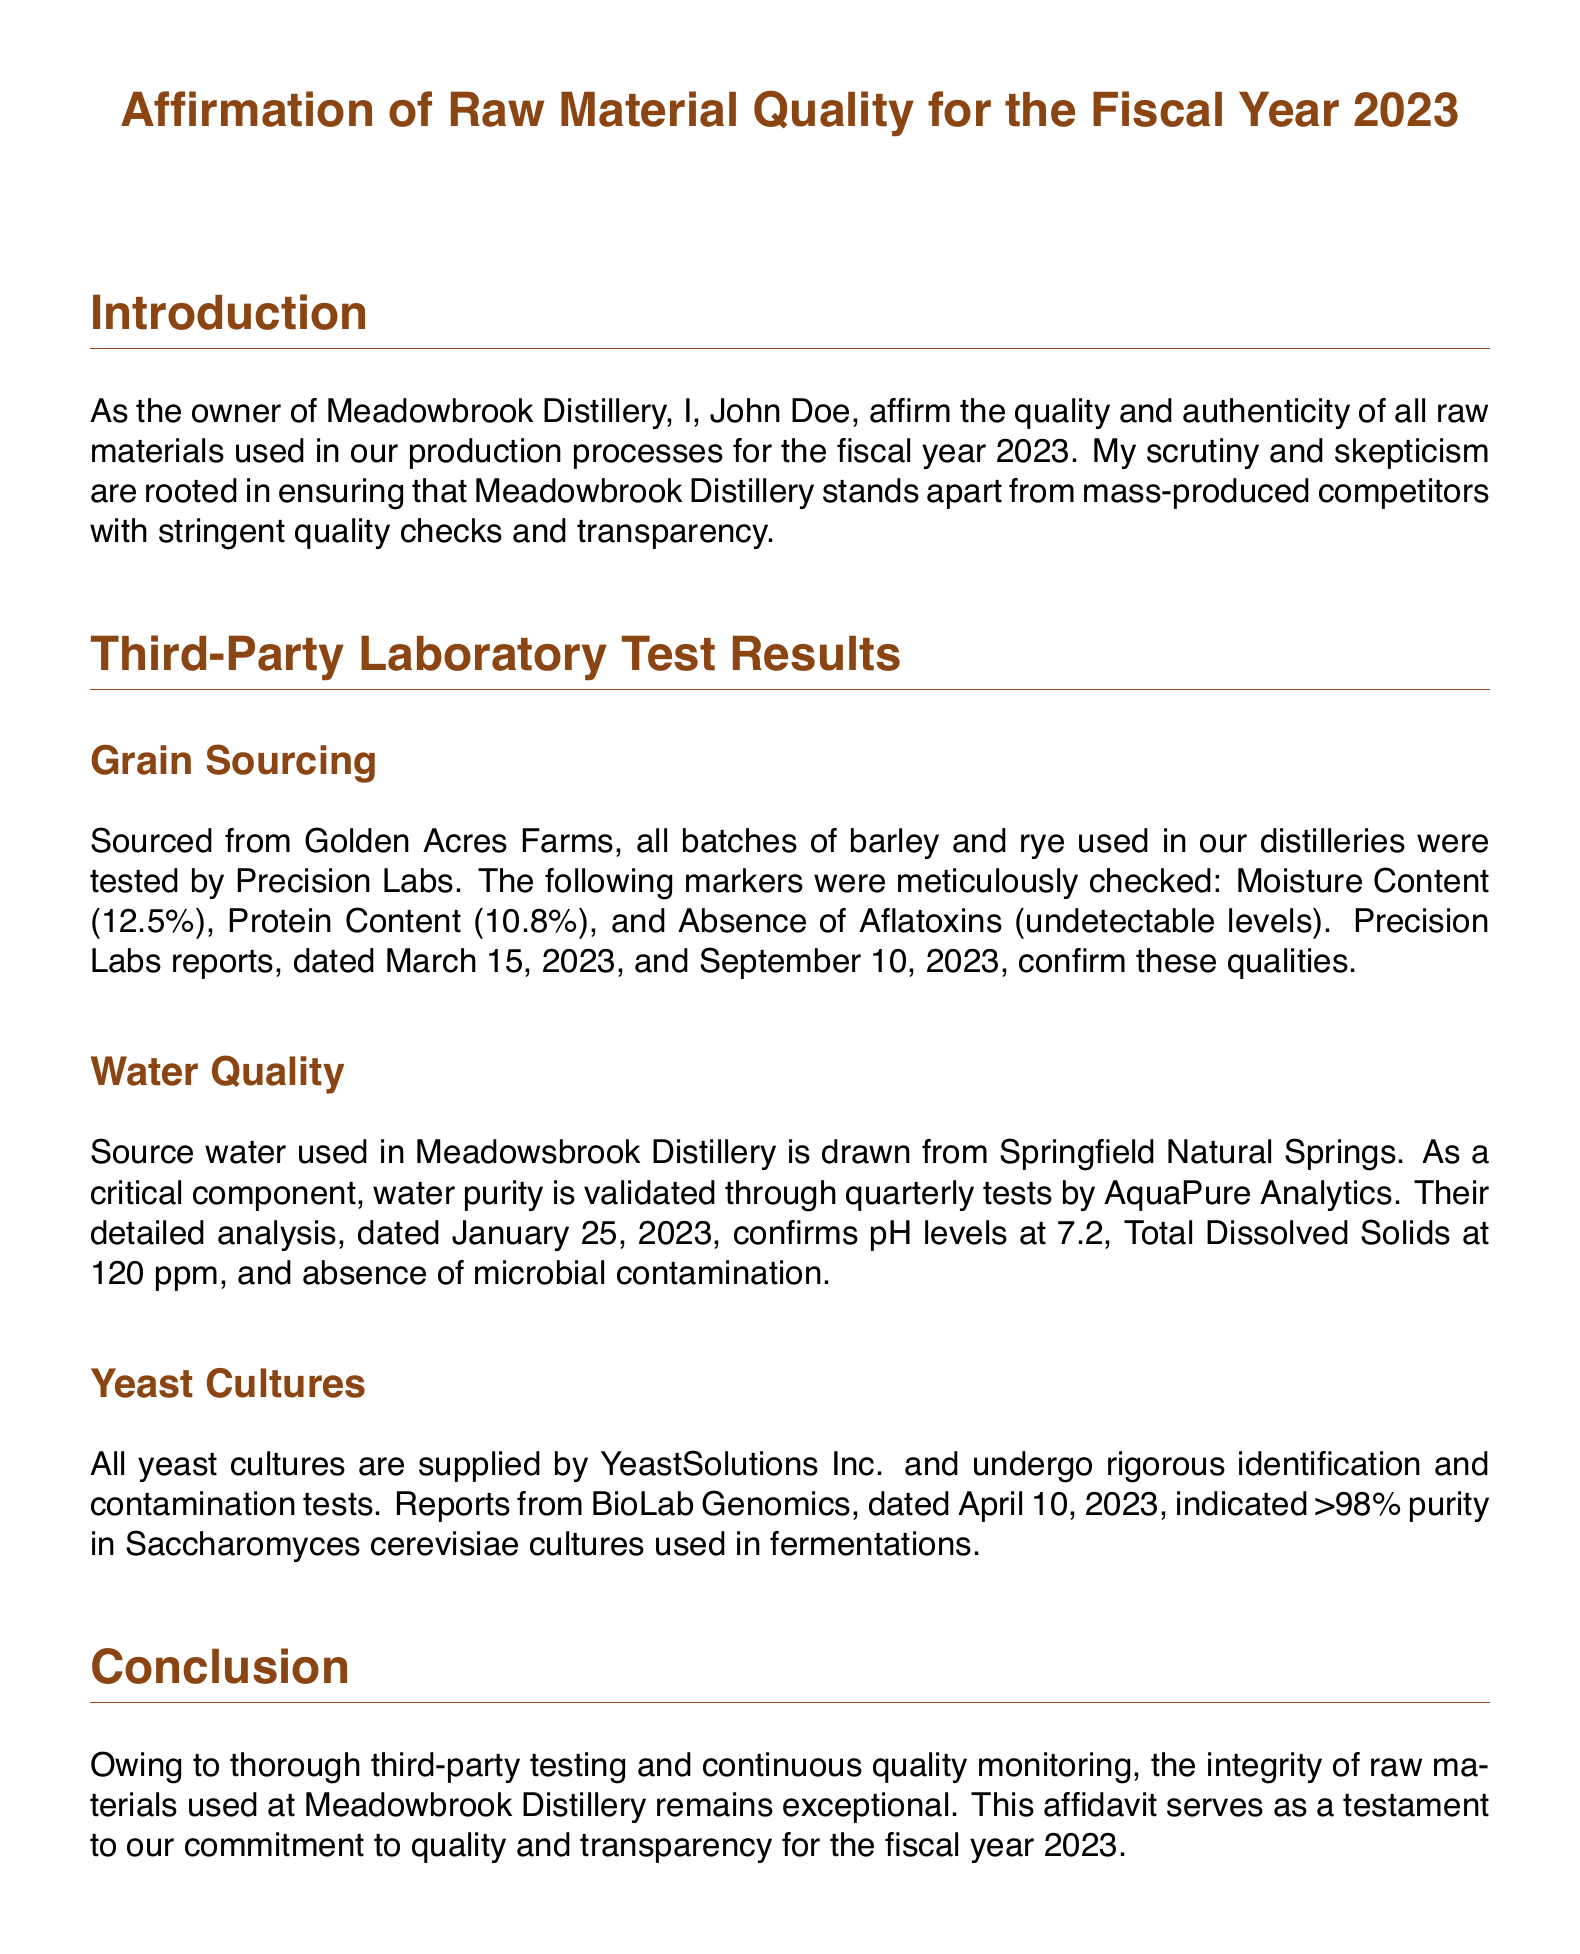What is the name of the distillery owner? The affidavit states the owner as John Doe.
Answer: John Doe What is the date of the affidavit? The document indicates the date at the bottom signed by John Doe, which is essential for its validity.
Answer: October 15, 2023 What laboratory tested the grain quality? The document specifies Precision Labs as the laboratory conducting grain tests in the section about grain sourcing.
Answer: Precision Labs What was the moisture content of the barley and rye? The specific moisture content value is listed in the testing results under grain sourcing, which indicates quality.
Answer: 12.5% What were the pH levels confirmed by AquaPure Analytics? The pH levels are mentioned as part of the water quality testing results in the relevant section of the affidavit.
Answer: 7.2 What is the purity percentage of yeast cultures used? The report from BioLab Genomics indicates the purity of Saccharomyces cerevisiae cultures, reflecting the quality checks in place.
Answer: >98% When was the water quality tested? The affidavit mentions a specific date for the water quality test which provides insight into the monitoring frequency.
Answer: January 25, 2023 What source does the water for the distillery come from? The document clearly states where the source water is drawn from, which is crucial to understanding its quality.
Answer: Springfield Natural Springs What is the absence of aflatoxins measured in batches of grain? The result confirming the absence of undesirable contaminants is highlighted in the grain sourcing section.
Answer: undetectable levels 